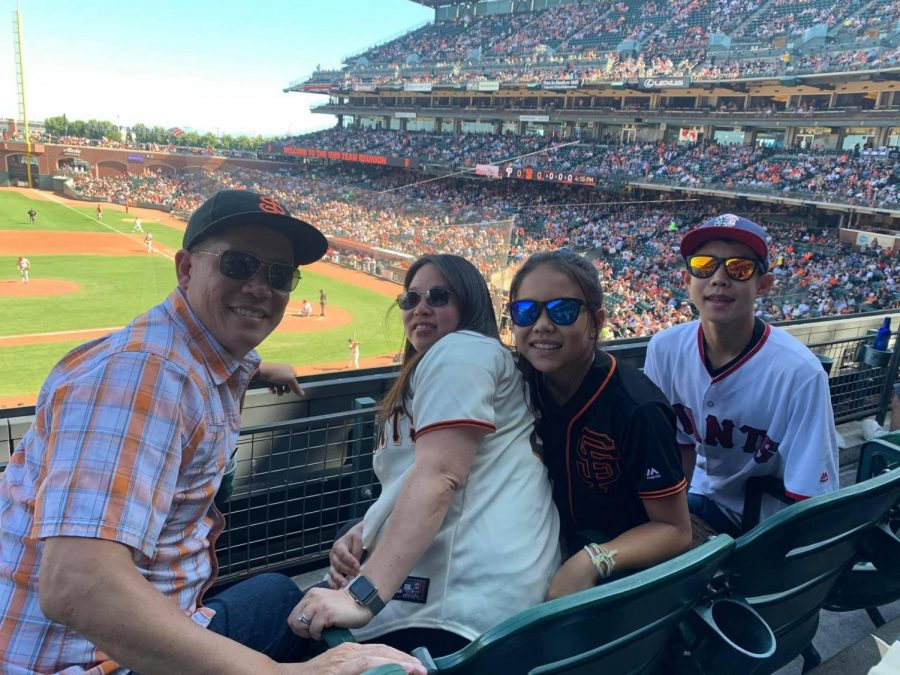Imagine if this stadium were part of a grand fantasy world. What kind of extraordinary creatures and events might take place here? In a grand fantasy world, this stadium could be the arena for majestic dragon races, where these powerful creatures soar through the skies, competing in aerial feats of strength and agility. The spectators are a mix of humans, elves, and various mythical beings, all cheering for their favorite dragons and riders. Between races, magical duels might occur on the field, with wizards casting dazzling spells that light up the stadium. Vendors sell enchanted snacks that float to you upon command, and mystical creatures like griffins and unicorns wander among the crowd, adding to the magical atmosphere. The grand finale could be a spectacular fireworks display, where enchanted fireworks dance in synchronization with a spellbinding light show, leaving the audience in awe. How would the atmosphere change during a championship game in such a fantastical setting? During a championship game, the atmosphere would be electric. The stadium is packed to the brim, with flags and banners fluttering in the wind. The tension is palpable as the best dragon riders in the realm compete for the ultimate title. A sense of anticipation and excitement fills the air as the crowd waits for the races to begin. Spectators are entertained by pre-game performances featuring creatures like phoenixes and sprites, dancing and weaving intricate patterns in the sky. As the races commence, the roar of the crowd reaches a fever pitch, with every twist, turn, and near-miss eliciting gasps and cheers. The culmination of the event would see the victors crowned in a grand ceremony, where a shower of enchanted flowers and sparkles rain down from the sky, marking the end of an unforgettable day. 